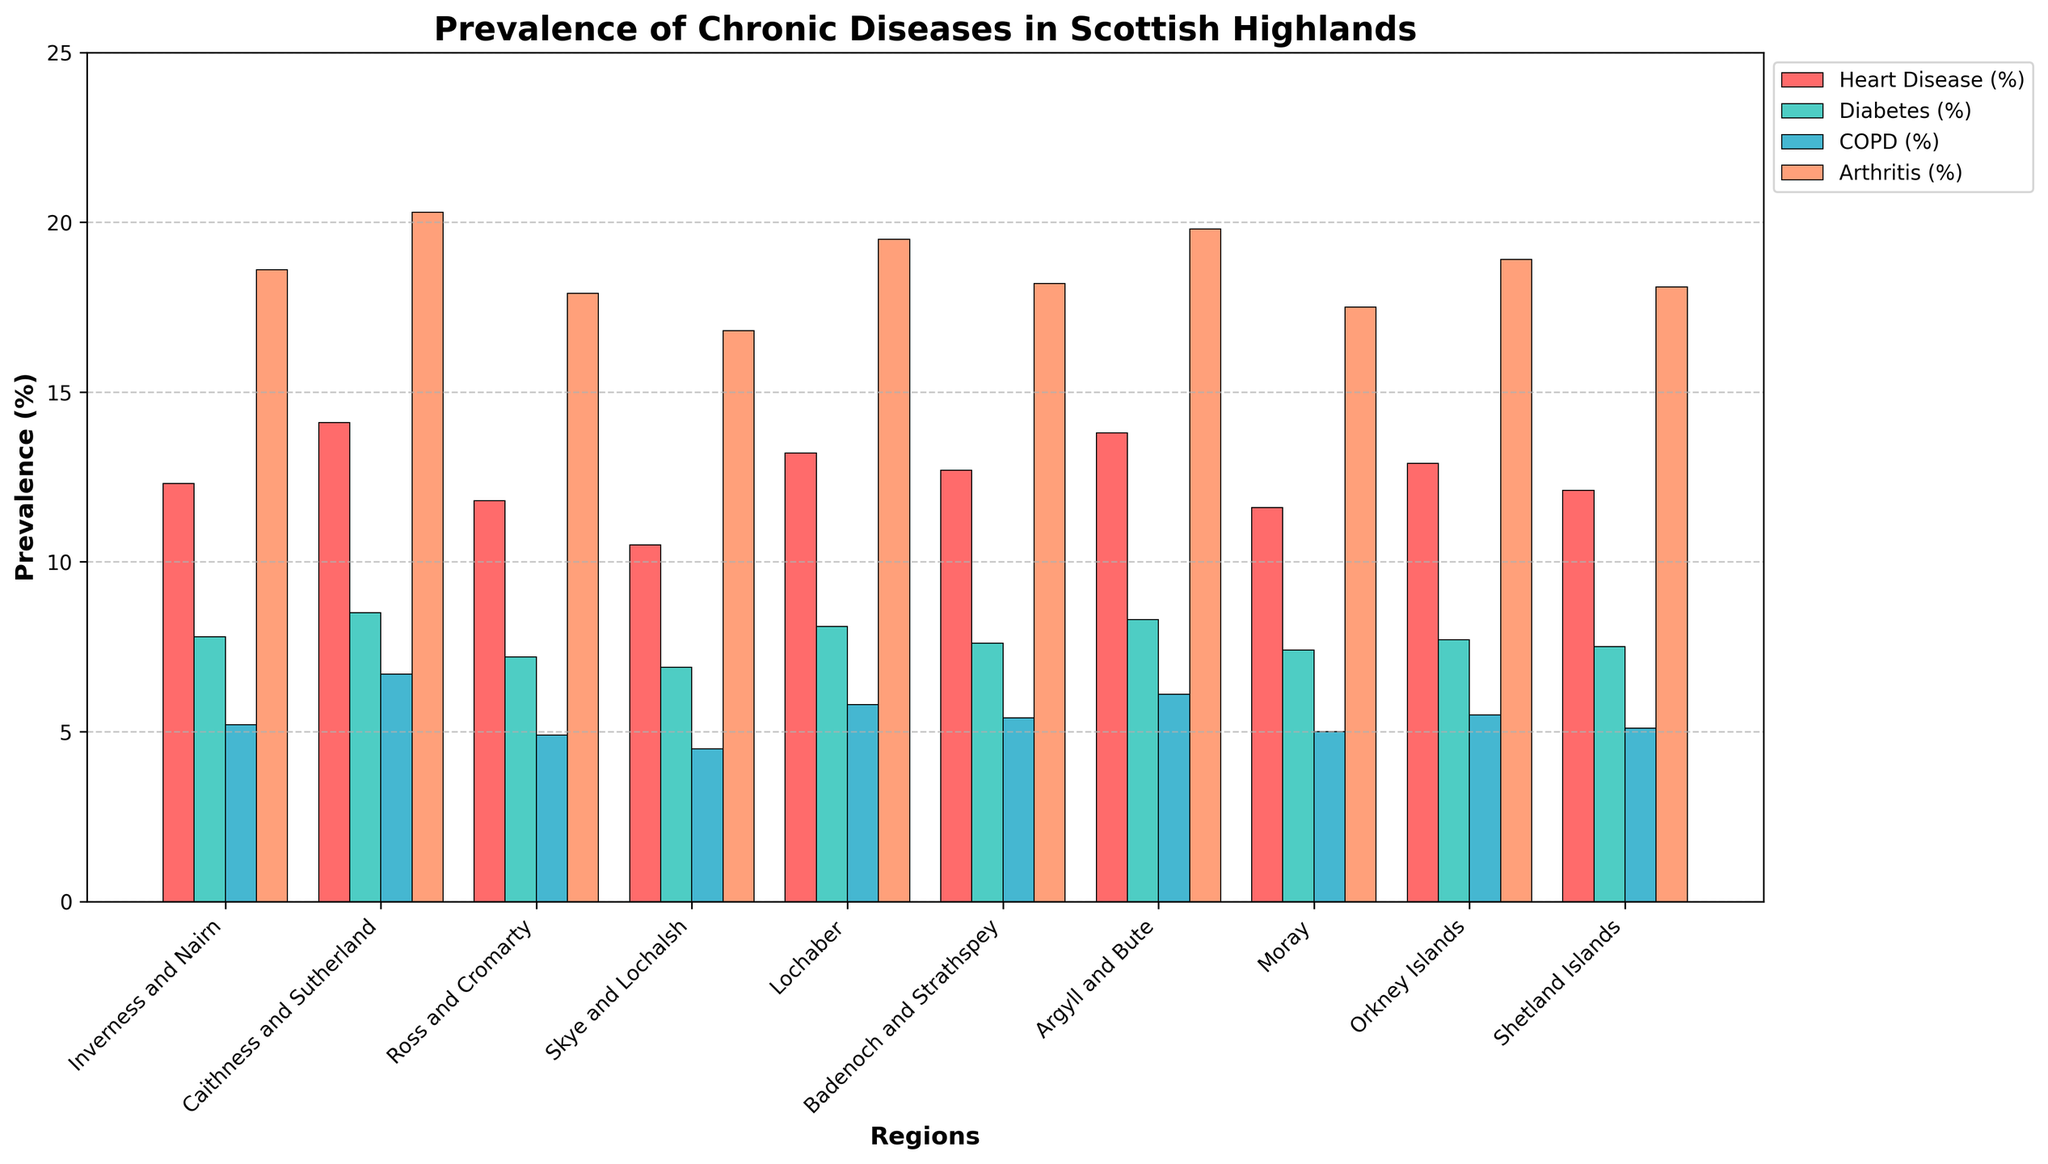Which region has the highest prevalence of Diabetes (%)? Look for the bar representing Diabetes (%) and compare the heights. The highest bar is in Caithness and Sutherland.
Answer: Caithness and Sutherland Which disease has the lowest prevalence in Skye and Lochalsh? Observe the bars corresponding to Skye and Lochalsh. The smallest bar represents COPD (%).
Answer: COPD (%) What is the difference in Arthritis (%) prevalence between Inverness and Nairn and Ross and Cromarty? Compare the heights of the Arthritis (%) bars in both regions. The difference is 18.6 - 17.9 = 0.7.
Answer: 0.7 Which region has the highest combined prevalence of Heart Disease (%) and COPD (%)? Add the values of Heart Disease (%) and COPD (%) for each region and compare. Caithness and Sutherland has the highest combined value (14.1 + 6.7 = 20.8).
Answer: Caithness and Sutherland What is the average prevalence of COPD (%) across all regions? Sum the COPD (%) values for all regions and divide by the number of regions (5.2 + 6.7 + 4.9 + 4.5 + 5.8 + 5.4 + 6.1 + 5.0 + 5.5 + 5.1 = 54.2 / 10 = 5.42).
Answer: 5.42 Which disease in Lochaber has a similar prevalence to Heart Disease (%) in Badenoch and Strathspey? Compare the bars. Heart Disease (%) in Badenoch and Strathspey is 12.7%, and Diabetes (%) in Lochaber is closest with 8.1%.
Answer: Diabetes (%) If you sum the prevalence of Diabetes (%) and Arthritis (%) in Argyll and Bute, what do you get? Add the values of Diabetes (%) and Arthritis (%) in Argyll and Bute (8.3 + 19.8 = 28.1).
Answer: 28.1 Which region has the smallest gap between the prevalence of Heart Disease (%) and Arthritis (%)? Calculate the difference for each region and compare. Ross and Cromarty has the smallest gap (18.6 - 11.8 = 5).
Answer: Ross and Cromarty In terms of visual attributes, which disease uses a blue color on the bars? Look at the colors of the bars and identify which disease uses blue.
Answer: COPD (%) If the heights of the bars representing Heart Disease (%) in Inverness and Nairn and Moray are summed, how tall would the resulting bar be? Sum the heights of the Heart Disease (%) bars in Inverness and Nairn and Moray (12.3 + 11.6 = 23.9).
Answer: 23.9 